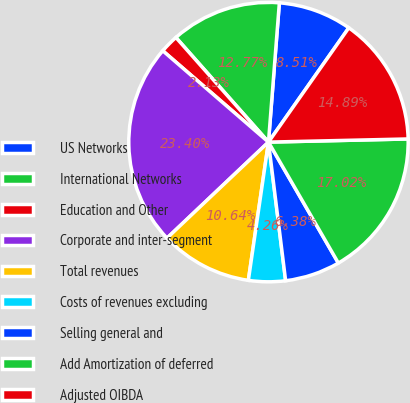Convert chart to OTSL. <chart><loc_0><loc_0><loc_500><loc_500><pie_chart><fcel>US Networks<fcel>International Networks<fcel>Education and Other<fcel>Corporate and inter-segment<fcel>Total revenues<fcel>Costs of revenues excluding<fcel>Selling general and<fcel>Add Amortization of deferred<fcel>Adjusted OIBDA<nl><fcel>8.51%<fcel>12.77%<fcel>2.13%<fcel>23.4%<fcel>10.64%<fcel>4.26%<fcel>6.38%<fcel>17.02%<fcel>14.89%<nl></chart> 